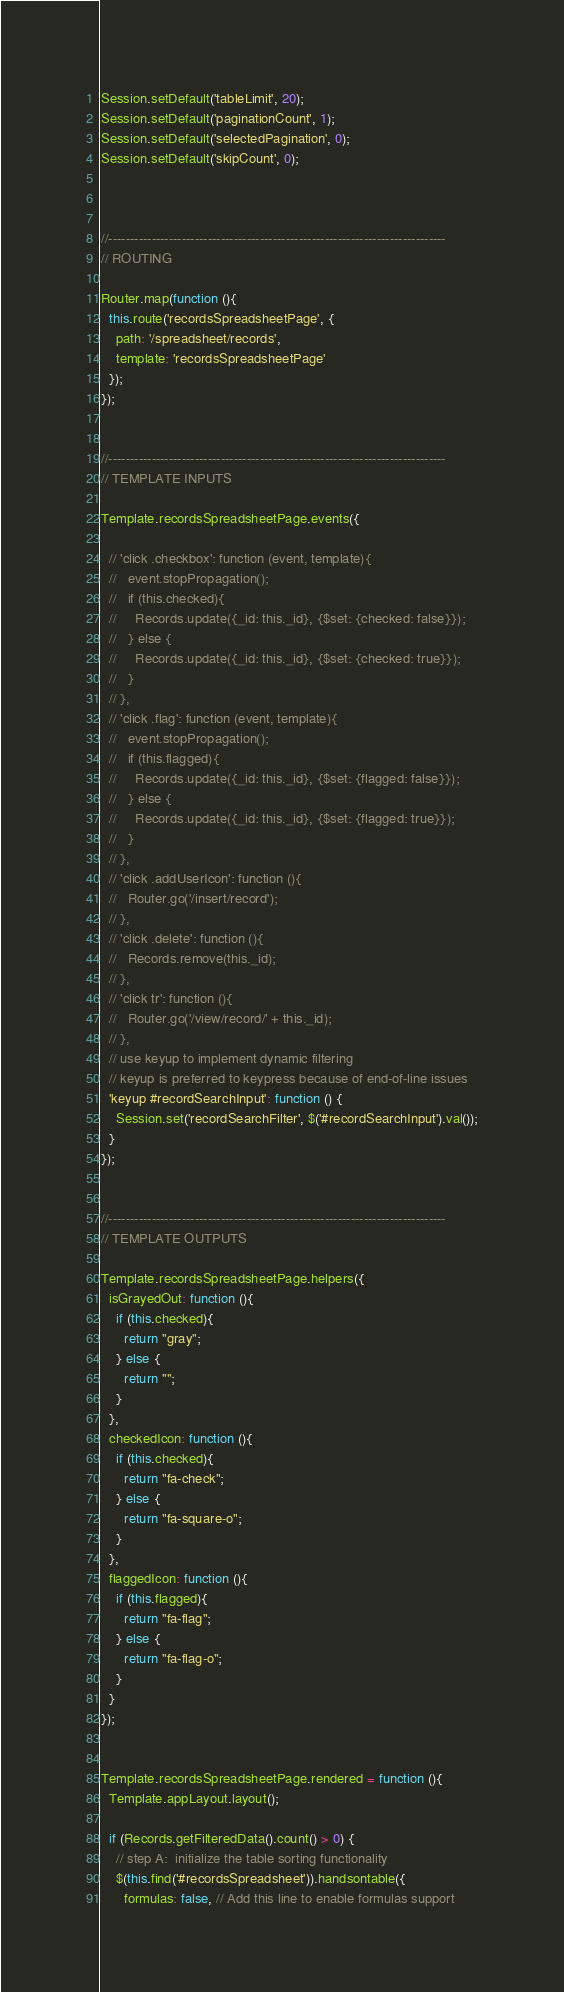<code> <loc_0><loc_0><loc_500><loc_500><_JavaScript_>
Session.setDefault('tableLimit', 20);
Session.setDefault('paginationCount', 1);
Session.setDefault('selectedPagination', 0);
Session.setDefault('skipCount', 0);



//------------------------------------------------------------------------------
// ROUTING

Router.map(function (){
  this.route('recordsSpreadsheetPage', {
    path: '/spreadsheet/records',
    template: 'recordsSpreadsheetPage'
  });
});


//------------------------------------------------------------------------------
// TEMPLATE INPUTS

Template.recordsSpreadsheetPage.events({

  // 'click .checkbox': function (event, template){
  //   event.stopPropagation();
  //   if (this.checked){
  //     Records.update({_id: this._id}, {$set: {checked: false}});
  //   } else {
  //     Records.update({_id: this._id}, {$set: {checked: true}});
  //   }
  // },
  // 'click .flag': function (event, template){
  //   event.stopPropagation();
  //   if (this.flagged){
  //     Records.update({_id: this._id}, {$set: {flagged: false}});
  //   } else {
  //     Records.update({_id: this._id}, {$set: {flagged: true}});
  //   }
  // },
  // 'click .addUserIcon': function (){
  //   Router.go('/insert/record');
  // },
  // 'click .delete': function (){
  //   Records.remove(this._id);
  // },
  // 'click tr': function (){
  //   Router.go('/view/record/' + this._id);
  // },
  // use keyup to implement dynamic filtering
  // keyup is preferred to keypress because of end-of-line issues
  'keyup #recordSearchInput': function () {
    Session.set('recordSearchFilter', $('#recordSearchInput').val());
  }
});


//------------------------------------------------------------------------------
// TEMPLATE OUTPUTS

Template.recordsSpreadsheetPage.helpers({
  isGrayedOut: function (){
    if (this.checked){
      return "gray";
    } else {
      return "";
    }
  },
  checkedIcon: function (){
    if (this.checked){
      return "fa-check";
    } else {
      return "fa-square-o";
    }
  },
  flaggedIcon: function (){
    if (this.flagged){
      return "fa-flag";
    } else {
      return "fa-flag-o";
    }
  }
});


Template.recordsSpreadsheetPage.rendered = function (){
  Template.appLayout.layout();

  if (Records.getFilteredData().count() > 0) {
    // step A:  initialize the table sorting functionality
    $(this.find('#recordsSpreadsheet')).handsontable({
      formulas: false, // Add this line to enable formulas support</code> 